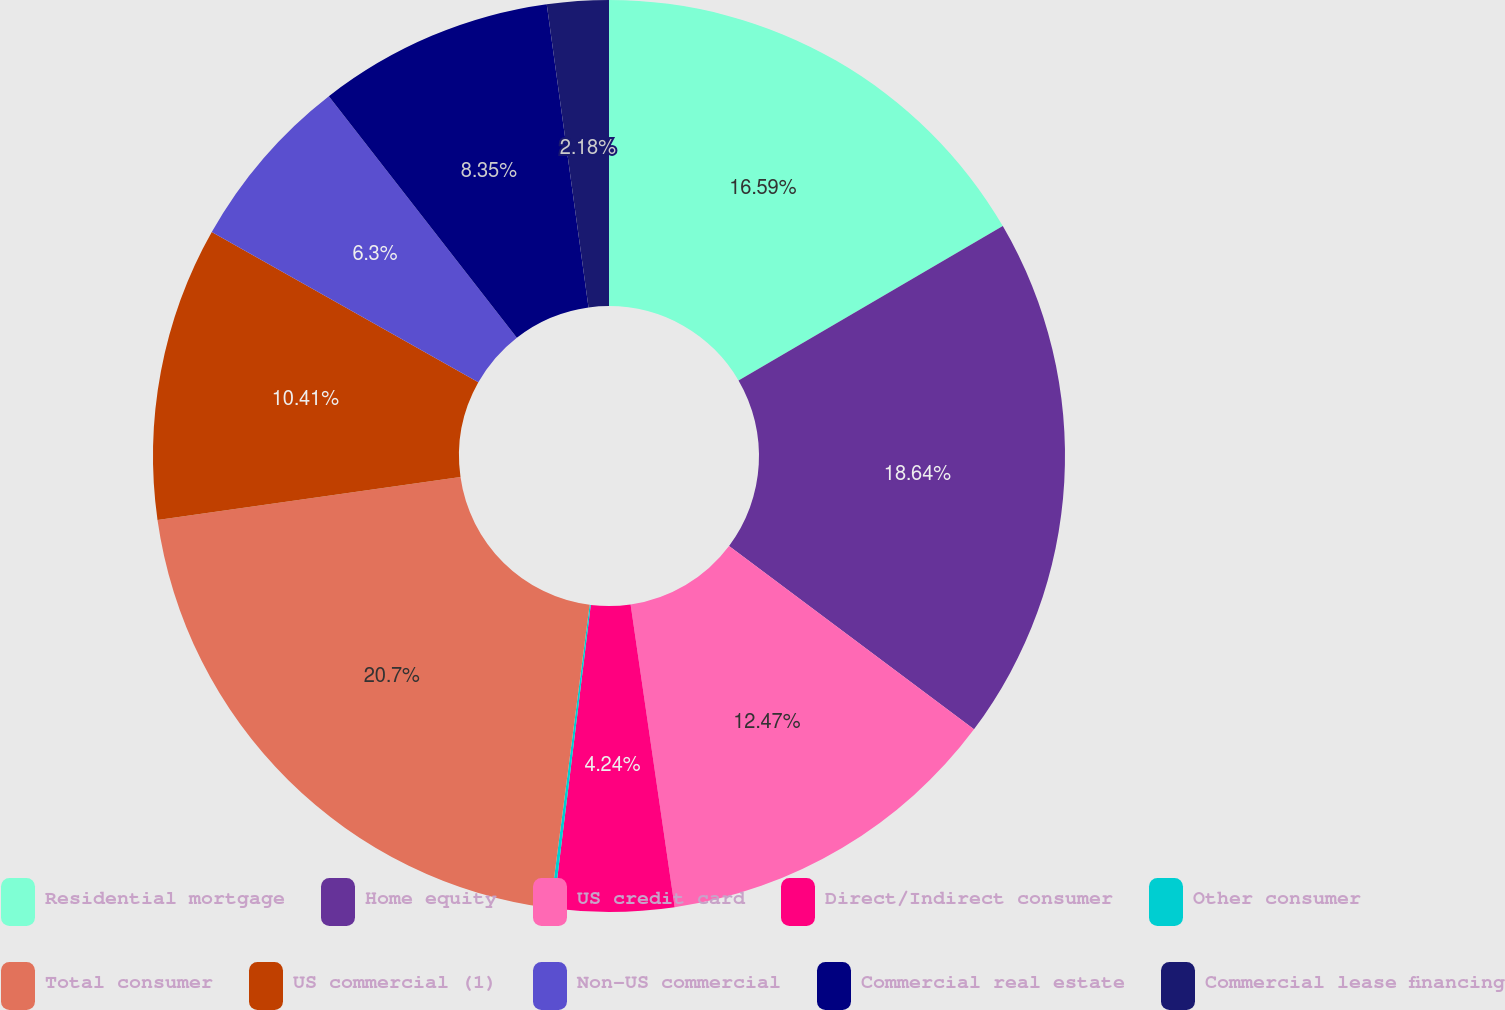Convert chart to OTSL. <chart><loc_0><loc_0><loc_500><loc_500><pie_chart><fcel>Residential mortgage<fcel>Home equity<fcel>US credit card<fcel>Direct/Indirect consumer<fcel>Other consumer<fcel>Total consumer<fcel>US commercial (1)<fcel>Non-US commercial<fcel>Commercial real estate<fcel>Commercial lease financing<nl><fcel>16.59%<fcel>18.64%<fcel>12.47%<fcel>4.24%<fcel>0.12%<fcel>20.7%<fcel>10.41%<fcel>6.3%<fcel>8.35%<fcel>2.18%<nl></chart> 